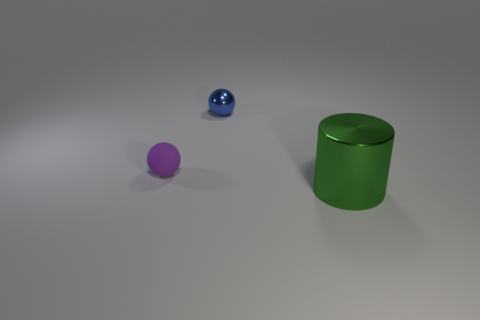If these objects were part of a game, what could be the rules? Imagining a game, one rule could be to roll the spheres to knock over the cylinder, similar to bowling. Points could be awarded based on the number of attempts needed. The different materials of the spheres could add complexity, with the rubber sphere having different rolling properties compared to the metallic one. 